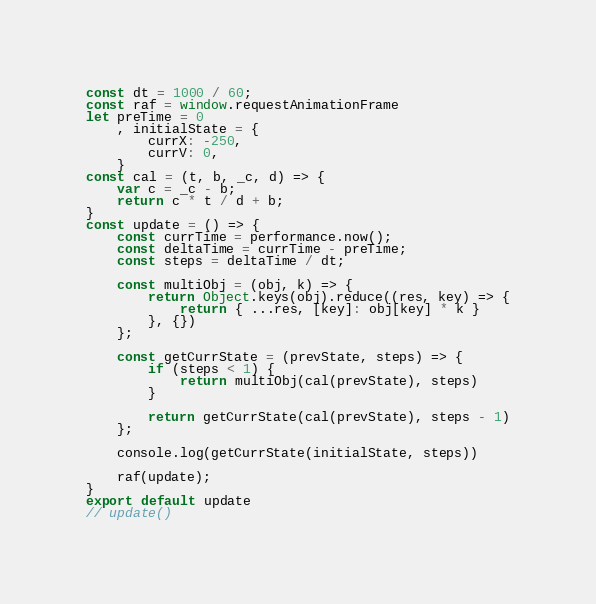<code> <loc_0><loc_0><loc_500><loc_500><_JavaScript_>const dt = 1000 / 60;
const raf = window.requestAnimationFrame
let preTime = 0
    , initialState = {
        currX: -250,
        currV: 0,
    }
const cal = (t, b, _c, d) => {
    var c = _c - b;
    return c * t / d + b;
}
const update = () => {
    const currTime = performance.now();
    const deltaTime = currTime - preTime;
    const steps = deltaTime / dt;

    const multiObj = (obj, k) => {
        return Object.keys(obj).reduce((res, key) => {
            return { ...res, [key]: obj[key] * k }
        }, {})
    };

    const getCurrState = (prevState, steps) => {
        if (steps < 1) {
            return multiObj(cal(prevState), steps)
        }

        return getCurrState(cal(prevState), steps - 1)
    };

    console.log(getCurrState(initialState, steps))

    raf(update);
}
export default update
// update()</code> 